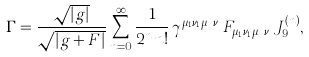Convert formula to latex. <formula><loc_0><loc_0><loc_500><loc_500>\Gamma = \frac { \sqrt { | g | } } { \sqrt { | g + F | } } \sum _ { n = 0 } ^ { \infty } \frac { 1 } { 2 ^ { n } n ! } \, \gamma ^ { \mu _ { 1 } \nu _ { 1 } \cdots \mu _ { n } \nu _ { n } } F _ { \mu _ { 1 } \nu _ { 1 } \cdots \mu _ { n } \nu _ { n } } J ^ { ( n ) } _ { 9 } ,</formula> 